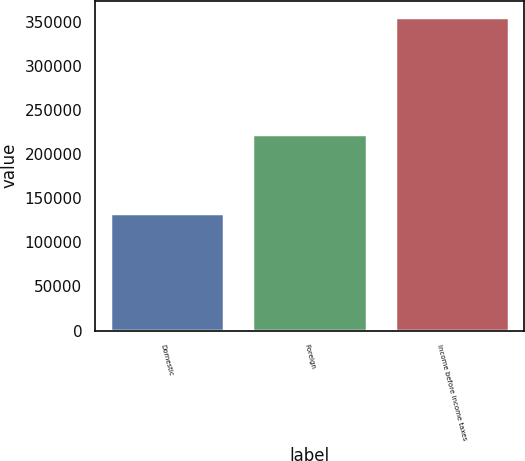Convert chart. <chart><loc_0><loc_0><loc_500><loc_500><bar_chart><fcel>Domestic<fcel>Foreign<fcel>Income before income taxes<nl><fcel>132916<fcel>223225<fcel>356141<nl></chart> 